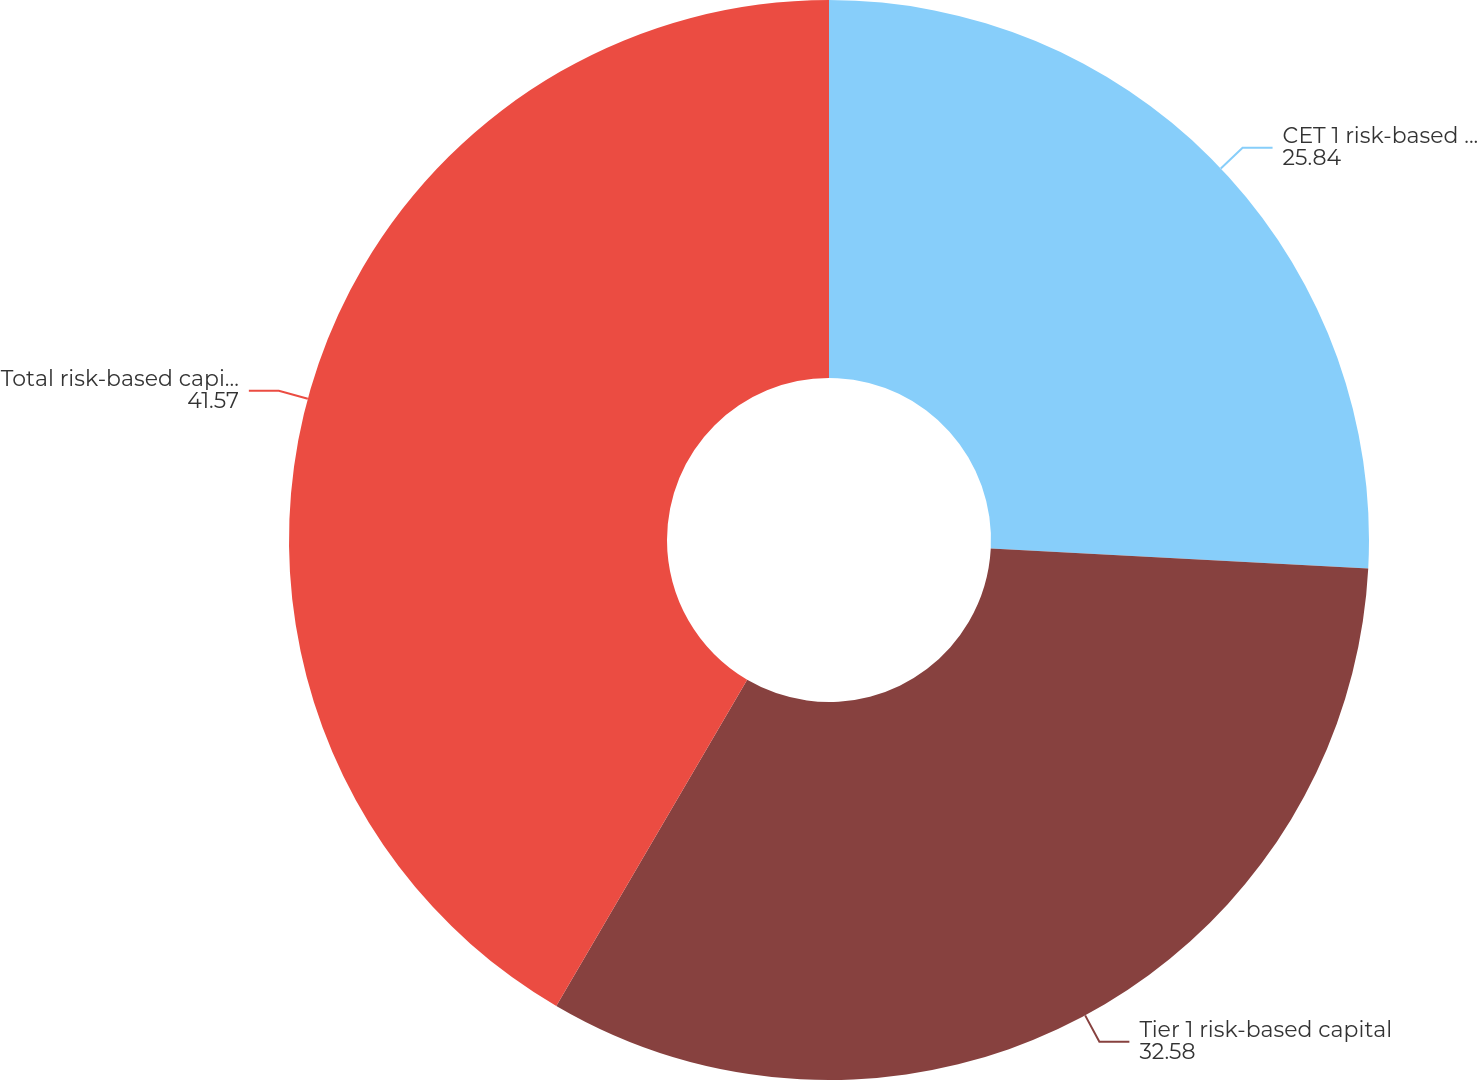Convert chart to OTSL. <chart><loc_0><loc_0><loc_500><loc_500><pie_chart><fcel>CET 1 risk-based capital ratio<fcel>Tier 1 risk-based capital<fcel>Total risk-based capital ratio<nl><fcel>25.84%<fcel>32.58%<fcel>41.57%<nl></chart> 